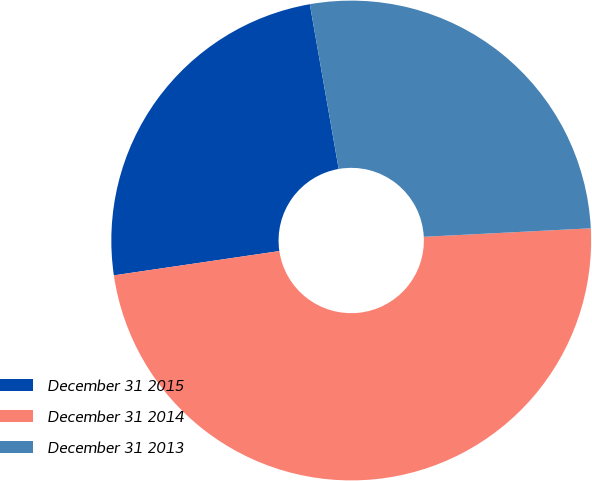Convert chart. <chart><loc_0><loc_0><loc_500><loc_500><pie_chart><fcel>December 31 2015<fcel>December 31 2014<fcel>December 31 2013<nl><fcel>24.56%<fcel>48.49%<fcel>26.95%<nl></chart> 